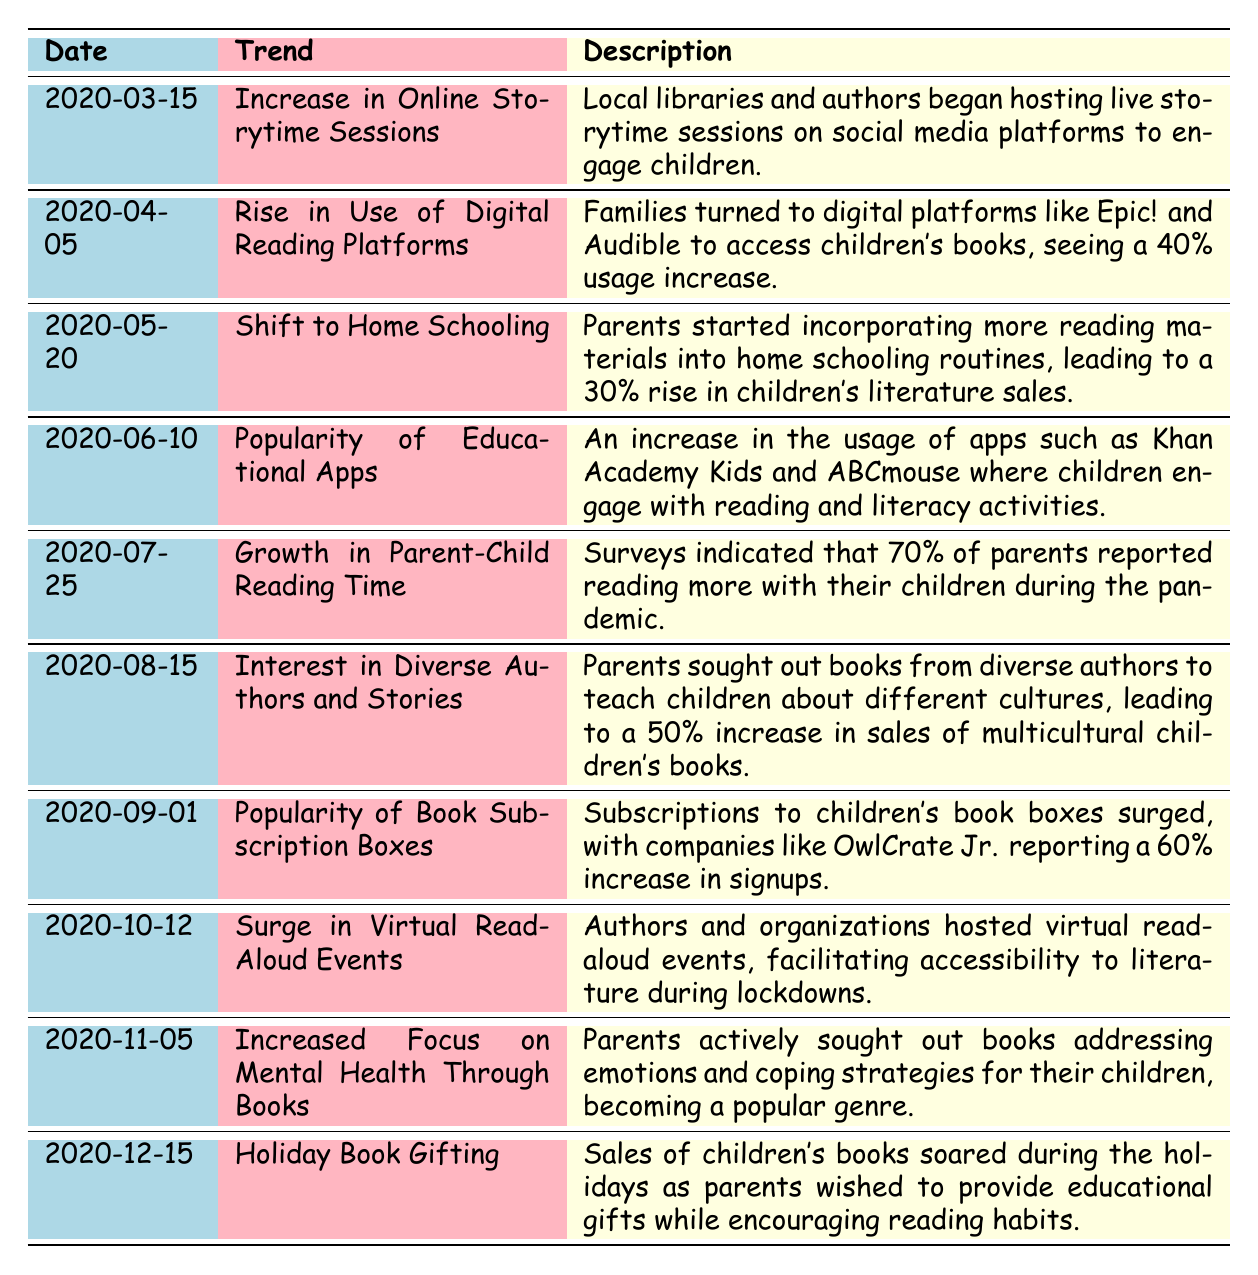What trend occurred on March 15, 2020? The table indicates that on March 15, 2020, the trend was an "Increase in Online Storytime Sessions," which explained that local libraries and authors began hosting live storytime sessions on social media platforms to engage children.
Answer: Increase in Online Storytime Sessions Which trend had the highest percentage increase? By comparing the percentage increases in the trends, the "Interest in Diverse Authors and Stories" had a 50% increase, which is the highest among all trends listed.
Answer: Interest in Diverse Authors and Stories Did the trend of increased focus on mental health through books occur before the holiday book gifting trend? Yes, the increased focus on mental health through books occurred on November 5, 2020, which is before the holiday book gifting trend on December 15, 2020.
Answer: Yes What percentage did families turn to digital reading platforms by April 5, 2020? The table specifies that families turned to digital reading platforms like Epic! and Audible with a 40% usage increase on April 5, 2020.
Answer: 40% Calculate the percentage increase in children's literature sales due to the shift to home schooling. The shift to home schooling led to a 30% rise in children's literature sales, as specifically mentioned in the trend description for May 20, 2020. There are no other relevant calculations needed for this question.
Answer: 30% Which trend showed a significant rise in parent-child reading time during the pandemic? The table indicates that on July 25, 2020, "Growth in Parent-Child Reading Time" was identified, with surveys suggesting that 70% of parents reported reading more with their children during the pandemic.
Answer: Growth in Parent-Child Reading Time What trend is associated with virtual read-aloud events and when did it occur? The trend associated with virtual read-aloud events is marked for October 12, 2020, where authors and organizations hosted these events to improve accessibility to literature during lockdowns.
Answer: Surge in Virtual Read-Aloud Events How many trends focused on digital platforms or apps? By examining the table, there are three trends that specifically focus on digital platforms or apps: "Rise in Use of Digital Reading Platforms," "Popularity of Educational Apps," and "Surge in Virtual Read-Aloud Events." Therefore, the total number of such trends is three.
Answer: Three 